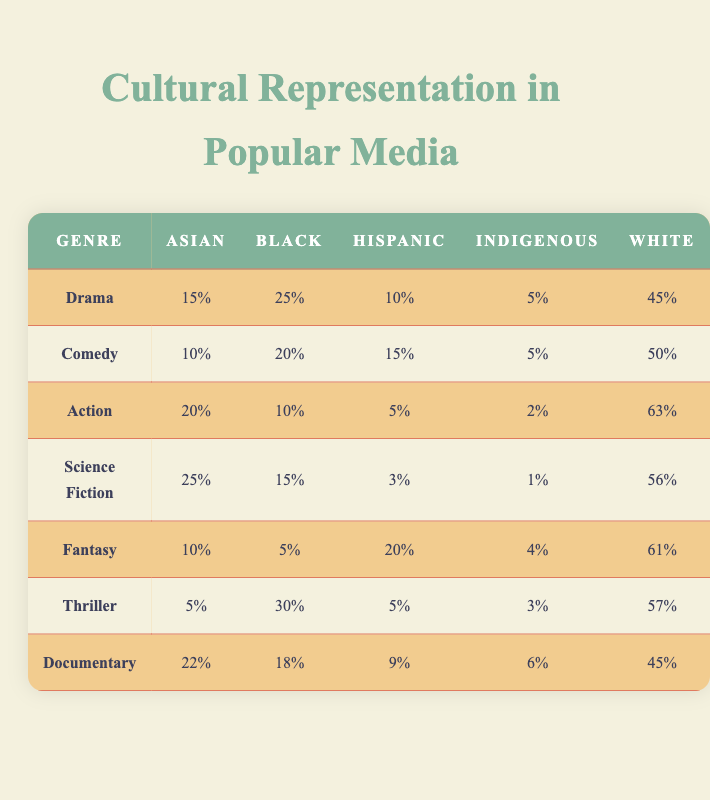What percentage of Black representation is found in the action genre? The table shows that the percentage of Black representation in the action genre is 10%.
Answer: 10% Which genre has the highest representation of Asian individuals? The action genre has the highest representation of Asian individuals at 20%.
Answer: 20% What is the total percentage of representation for Indigenous individuals across all genres? Adding the percentages for Indigenous individuals: 5% (Drama) + 5% (Comedy) + 2% (Action) + 1% (Science Fiction) + 4% (Fantasy) + 3% (Thriller) + 6% (Documentary) = 26%.
Answer: 26% Is the percentage of Hispanic representation in Fiction greater than that in Comedy? In the Fantasy genre, the percentage of Hispanic representation is 20%, which is greater than 15% in Comedy. Thus, the statement is true.
Answer: Yes Which genre has the largest difference between the highest and lowest representation percentages for White individuals? The Action genre shows the largest difference: 63% for White individuals and 45% (Documentary), so 63% - 45% = 18%.
Answer: 18% What is the average percentage of representation for Black individuals across all genres? Summing the percentages for Black individuals: 25% + 20% + 10% + 15% + 5% + 30% + 18% =  123%, and dividing by the number of genres (7) gives an average of 123% / 7 ≈ 17.57%.
Answer: 17.57% In which genre do Hispanics have the least representation? The Action genre has the least representation of Hispanic individuals at 5%.
Answer: 5% Is it true that the percentage of representation for White individuals in the Thriller genre is higher than that in the Comedy genre? The percentage of representation for White individuals in the Thriller genre (57%) is higher than in Comedy (50%), so the statement is true.
Answer: Yes What percentage of total representation do Asian individuals hold across all genres? Adding the percentages: 15% (Drama) + 10% (Comedy) + 20% (Action) + 25% (Science Fiction) + 10% (Fantasy) + 5% (Thriller) + 22% (Documentary) = 107%, and dividing by 7 gives approximately 15.29%.
Answer: 15.29% Which genres have a representation of Indigenous individuals that is less than 4%? The Action genre and Science Fiction have 2% and 1% respectively, which are both less than 4%.
Answer: Action, Science Fiction 